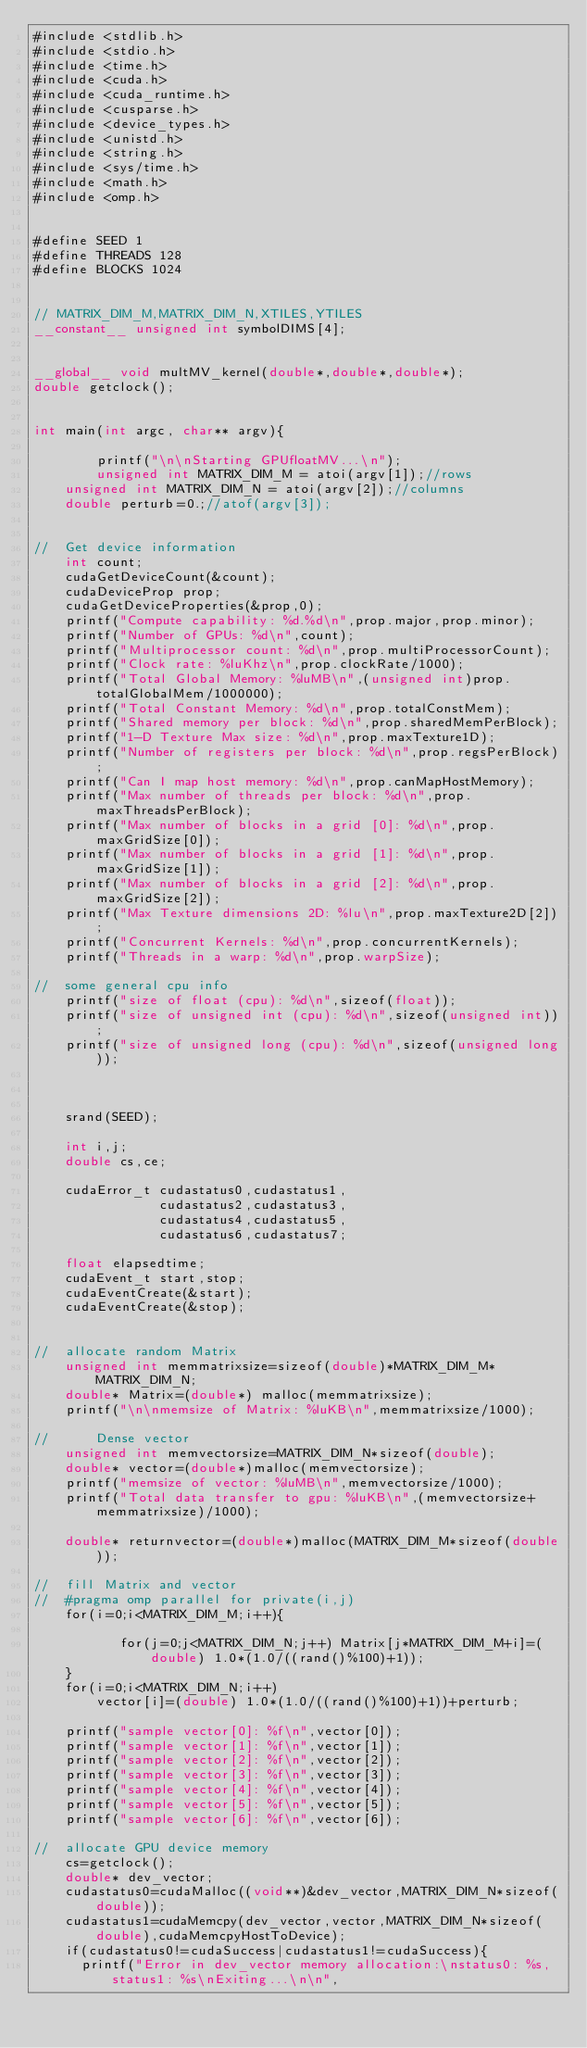<code> <loc_0><loc_0><loc_500><loc_500><_Cuda_>#include <stdlib.h>
#include <stdio.h>
#include <time.h>
#include <cuda.h>
#include <cuda_runtime.h>
#include <cusparse.h>
#include <device_types.h>
#include <unistd.h>
#include <string.h>
#include <sys/time.h>
#include <math.h>
#include <omp.h>


#define SEED 1
#define THREADS 128
#define BLOCKS 1024


// MATRIX_DIM_M,MATRIX_DIM_N,XTILES,YTILES
__constant__ unsigned int symbolDIMS[4];


__global__ void multMV_kernel(double*,double*,double*);
double getclock();


int main(int argc, char** argv){

        printf("\n\nStarting GPUfloatMV...\n");
        unsigned int MATRIX_DIM_M = atoi(argv[1]);//rows
	unsigned int MATRIX_DIM_N = atoi(argv[2]);//columns
	double perturb=0.;//atof(argv[3]);


//	Get device information
	int count;
	cudaGetDeviceCount(&count);
	cudaDeviceProp prop;
	cudaGetDeviceProperties(&prop,0);
	printf("Compute capability: %d.%d\n",prop.major,prop.minor);
	printf("Number of GPUs: %d\n",count);
	printf("Multiprocessor count: %d\n",prop.multiProcessorCount);
	printf("Clock rate: %luKhz\n",prop.clockRate/1000);
	printf("Total Global Memory: %luMB\n",(unsigned int)prop.totalGlobalMem/1000000);
	printf("Total Constant Memory: %d\n",prop.totalConstMem);
	printf("Shared memory per block: %d\n",prop.sharedMemPerBlock);
	printf("1-D Texture Max size: %d\n",prop.maxTexture1D);
	printf("Number of registers per block: %d\n",prop.regsPerBlock);
	printf("Can I map host memory: %d\n",prop.canMapHostMemory);
	printf("Max number of threads per block: %d\n",prop.maxThreadsPerBlock);
	printf("Max number of blocks in a grid [0]: %d\n",prop.maxGridSize[0]);
	printf("Max number of blocks in a grid [1]: %d\n",prop.maxGridSize[1]);
	printf("Max number of blocks in a grid [2]: %d\n",prop.maxGridSize[2]);
	printf("Max Texture dimensions 2D: %lu\n",prop.maxTexture2D[2]);
	printf("Concurrent Kernels: %d\n",prop.concurrentKernels);
	printf("Threads in a warp: %d\n",prop.warpSize);

//	some general cpu info
	printf("size of float (cpu): %d\n",sizeof(float));
	printf("size of unsigned int (cpu): %d\n",sizeof(unsigned int));
	printf("size of unsigned long (cpu): %d\n",sizeof(unsigned long));



	srand(SEED);

	int i,j;
	double cs,ce;

	cudaError_t cudastatus0,cudastatus1,
	            cudastatus2,cudastatus3,
	            cudastatus4,cudastatus5,
           	    cudastatus6,cudastatus7;

	float elapsedtime;
	cudaEvent_t start,stop;
	cudaEventCreate(&start);
	cudaEventCreate(&stop);

	
//	allocate random Matrix 
	unsigned int memmatrixsize=sizeof(double)*MATRIX_DIM_M*MATRIX_DIM_N;
	double* Matrix=(double*) malloc(memmatrixsize); 
	printf("\n\nmemsize of Matrix: %luKB\n",memmatrixsize/1000);

//      Dense vector
	unsigned int memvectorsize=MATRIX_DIM_N*sizeof(double);
	double* vector=(double*)malloc(memvectorsize);
	printf("memsize of vector: %luMB\n",memvectorsize/1000);
	printf("Total data transfer to gpu: %luKB\n",(memvectorsize+memmatrixsize)/1000);

	double* returnvector=(double*)malloc(MATRIX_DIM_M*sizeof(double));

//	fill Matrix and vector
//	#pragma omp parallel for private(i,j)
	for(i=0;i<MATRIX_DIM_M;i++){
           
           for(j=0;j<MATRIX_DIM_N;j++) Matrix[j*MATRIX_DIM_M+i]=(double) 1.0*(1.0/((rand()%100)+1));    
	}
	for(i=0;i<MATRIX_DIM_N;i++)
		vector[i]=(double) 1.0*(1.0/((rand()%100)+1))+perturb;

	printf("sample vector[0]: %f\n",vector[0]);
	printf("sample vector[1]: %f\n",vector[1]);
	printf("sample vector[2]: %f\n",vector[2]);
	printf("sample vector[3]: %f\n",vector[3]);
	printf("sample vector[4]: %f\n",vector[4]);
	printf("sample vector[5]: %f\n",vector[5]);
	printf("sample vector[6]: %f\n",vector[6]);

// 	allocate GPU device memory
	cs=getclock();
	double* dev_vector;
	cudastatus0=cudaMalloc((void**)&dev_vector,MATRIX_DIM_N*sizeof(double));
	cudastatus1=cudaMemcpy(dev_vector,vector,MATRIX_DIM_N*sizeof(double),cudaMemcpyHostToDevice);
	if(cudastatus0!=cudaSuccess|cudastatus1!=cudaSuccess){
	  printf("Error in dev_vector memory allocation:\nstatus0: %s, status1: %s\nExiting...\n\n",</code> 